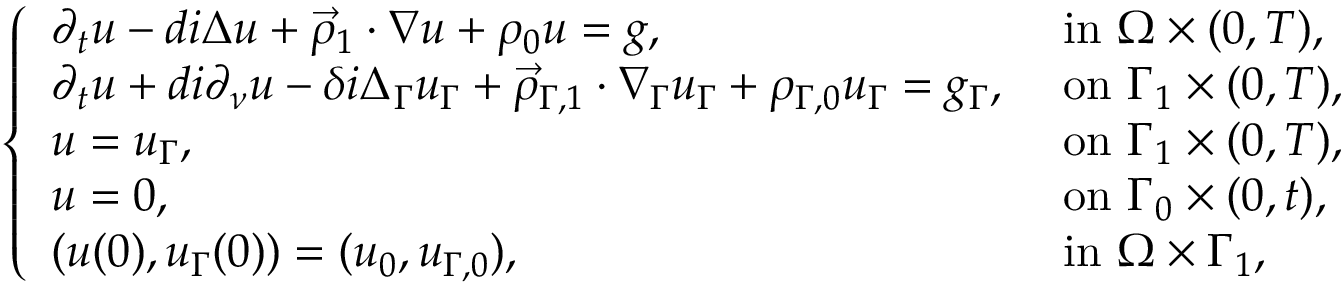Convert formula to latex. <formula><loc_0><loc_0><loc_500><loc_500>\begin{array} { r } { \left \{ \begin{array} { l l } { \partial _ { t } u - d i \Delta u + \vec { \rho } _ { 1 } \cdot \nabla u + \rho _ { 0 } u = g , } & { i n \Omega \times ( 0 , T ) , } \\ { \partial _ { t } u + d i \partial _ { \nu } u - \delta i \Delta _ { \Gamma } u _ { \Gamma } + \vec { \rho } _ { \Gamma , 1 } \cdot \nabla _ { \Gamma } u _ { \Gamma } + \rho _ { \Gamma , 0 } u _ { \Gamma } = g _ { \Gamma } , } & { o n \Gamma _ { 1 } \times ( 0 , T ) , } \\ { u = u _ { \Gamma } , } & { o n \Gamma _ { 1 } \times ( 0 , T ) , } \\ { u = 0 , } & { o n \Gamma _ { 0 } \times ( 0 , t ) , } \\ { ( u ( 0 ) , u _ { \Gamma } ( 0 ) ) = ( u _ { 0 } , u _ { \Gamma , 0 } ) , } & { i n \Omega \times \Gamma _ { 1 } , } \end{array} } \end{array}</formula> 